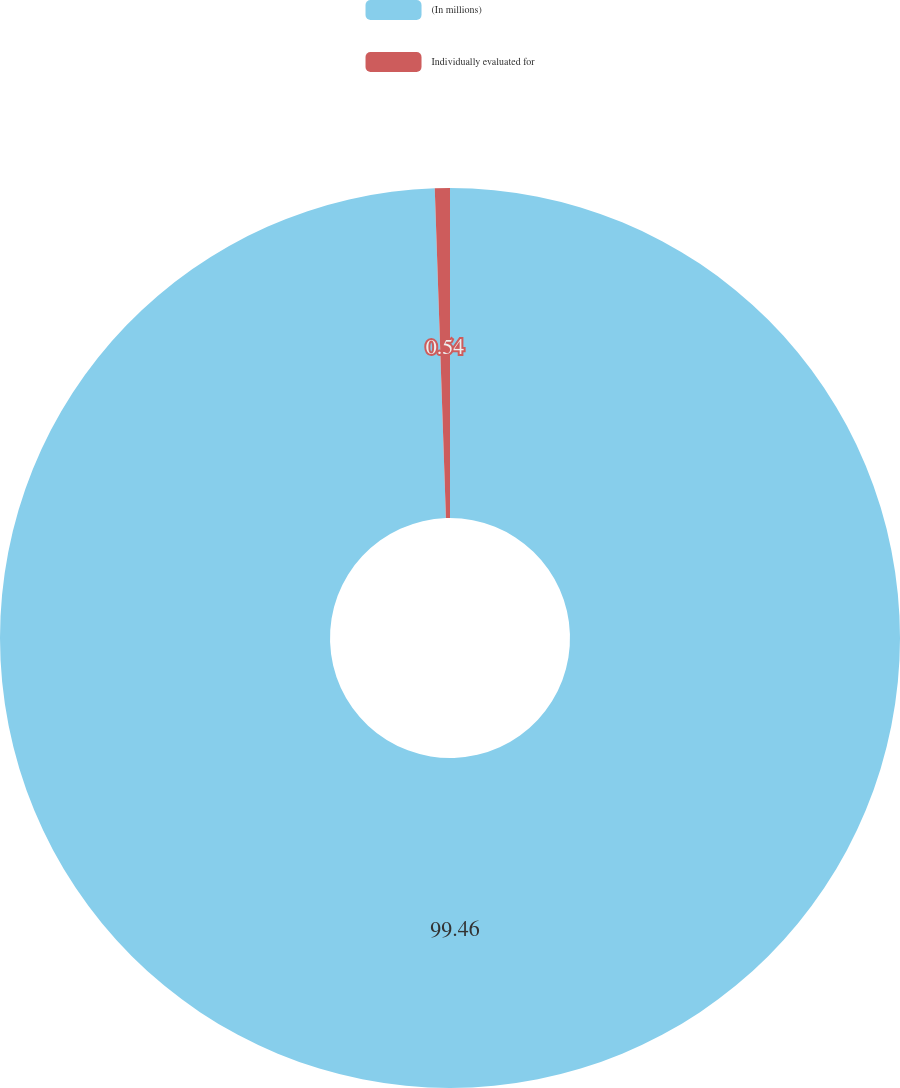<chart> <loc_0><loc_0><loc_500><loc_500><pie_chart><fcel>(In millions)<fcel>Individually evaluated for<nl><fcel>99.46%<fcel>0.54%<nl></chart> 